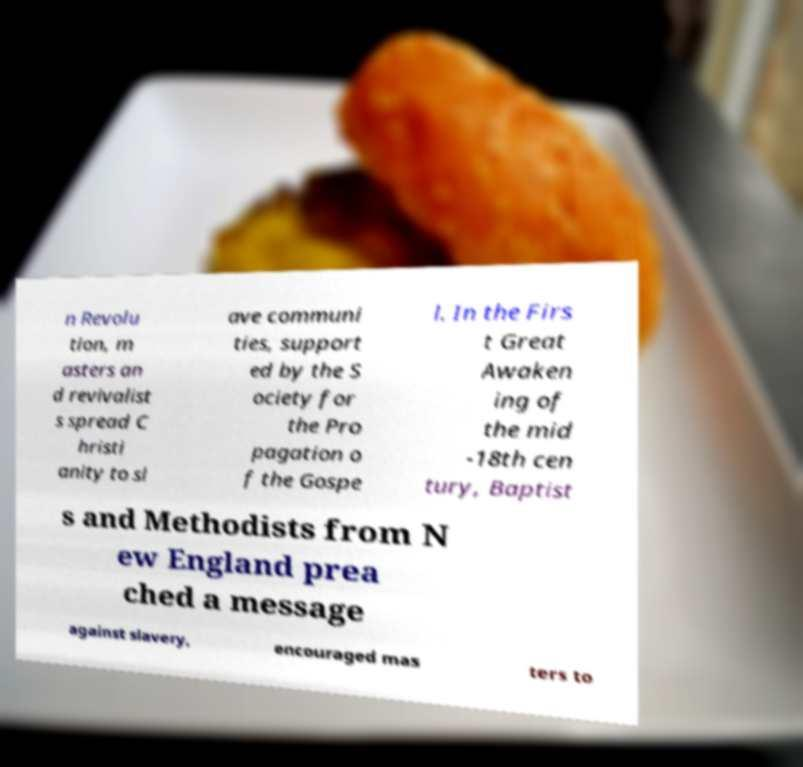There's text embedded in this image that I need extracted. Can you transcribe it verbatim? n Revolu tion, m asters an d revivalist s spread C hristi anity to sl ave communi ties, support ed by the S ociety for the Pro pagation o f the Gospe l. In the Firs t Great Awaken ing of the mid -18th cen tury, Baptist s and Methodists from N ew England prea ched a message against slavery, encouraged mas ters to 